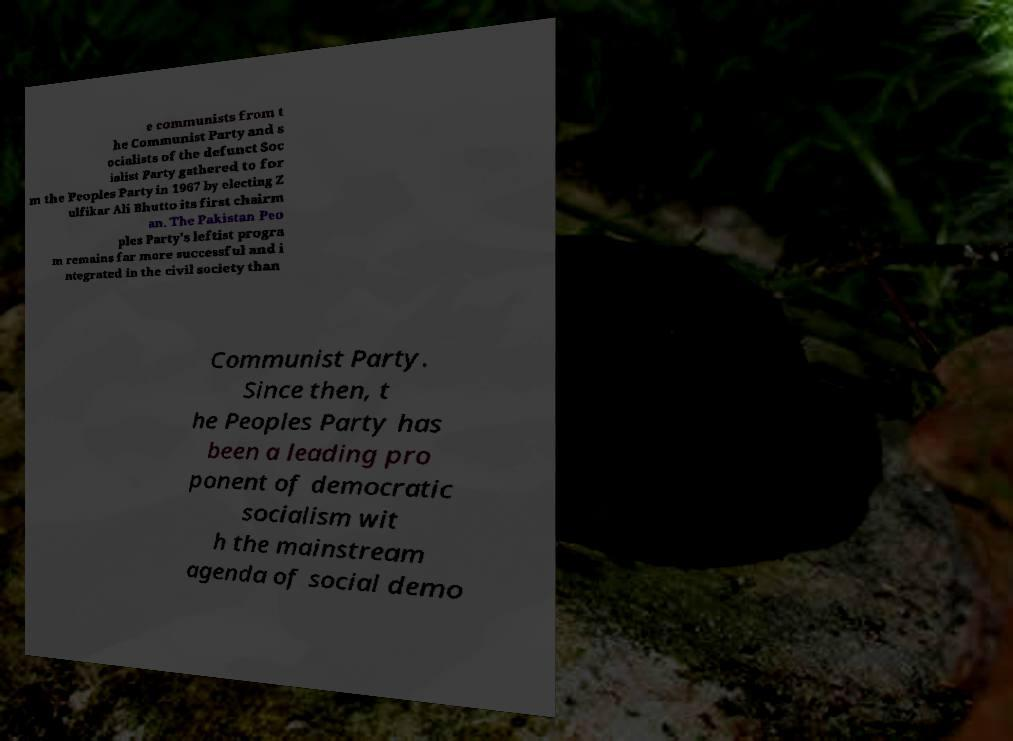What messages or text are displayed in this image? I need them in a readable, typed format. e communists from t he Communist Party and s ocialists of the defunct Soc ialist Party gathered to for m the Peoples Party in 1967 by electing Z ulfikar Ali Bhutto its first chairm an. The Pakistan Peo ples Party's leftist progra m remains far more successful and i ntegrated in the civil society than Communist Party. Since then, t he Peoples Party has been a leading pro ponent of democratic socialism wit h the mainstream agenda of social demo 